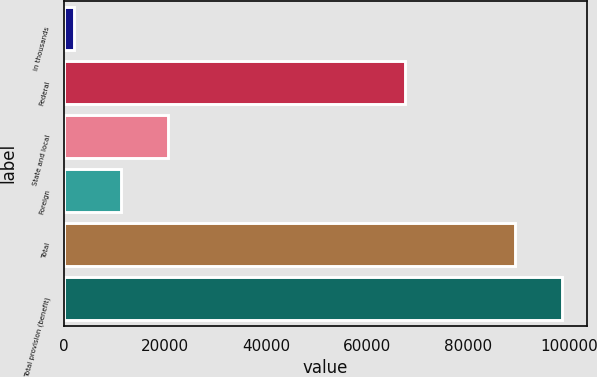<chart> <loc_0><loc_0><loc_500><loc_500><bar_chart><fcel>in thousands<fcel>Federal<fcel>State and local<fcel>Foreign<fcel>Total<fcel>Total provision (benefit)<nl><fcel>2015<fcel>67521<fcel>20600.6<fcel>11307.8<fcel>89340<fcel>98632.8<nl></chart> 